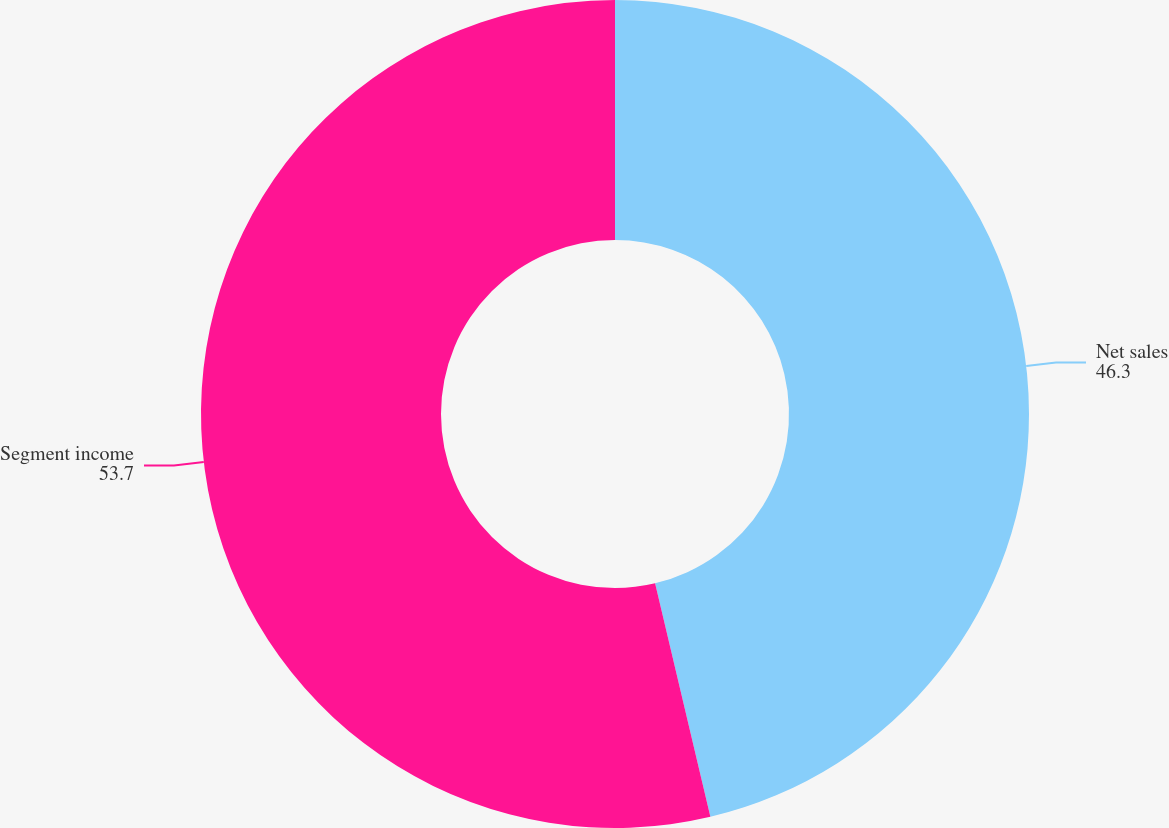Convert chart. <chart><loc_0><loc_0><loc_500><loc_500><pie_chart><fcel>Net sales<fcel>Segment income<nl><fcel>46.3%<fcel>53.7%<nl></chart> 